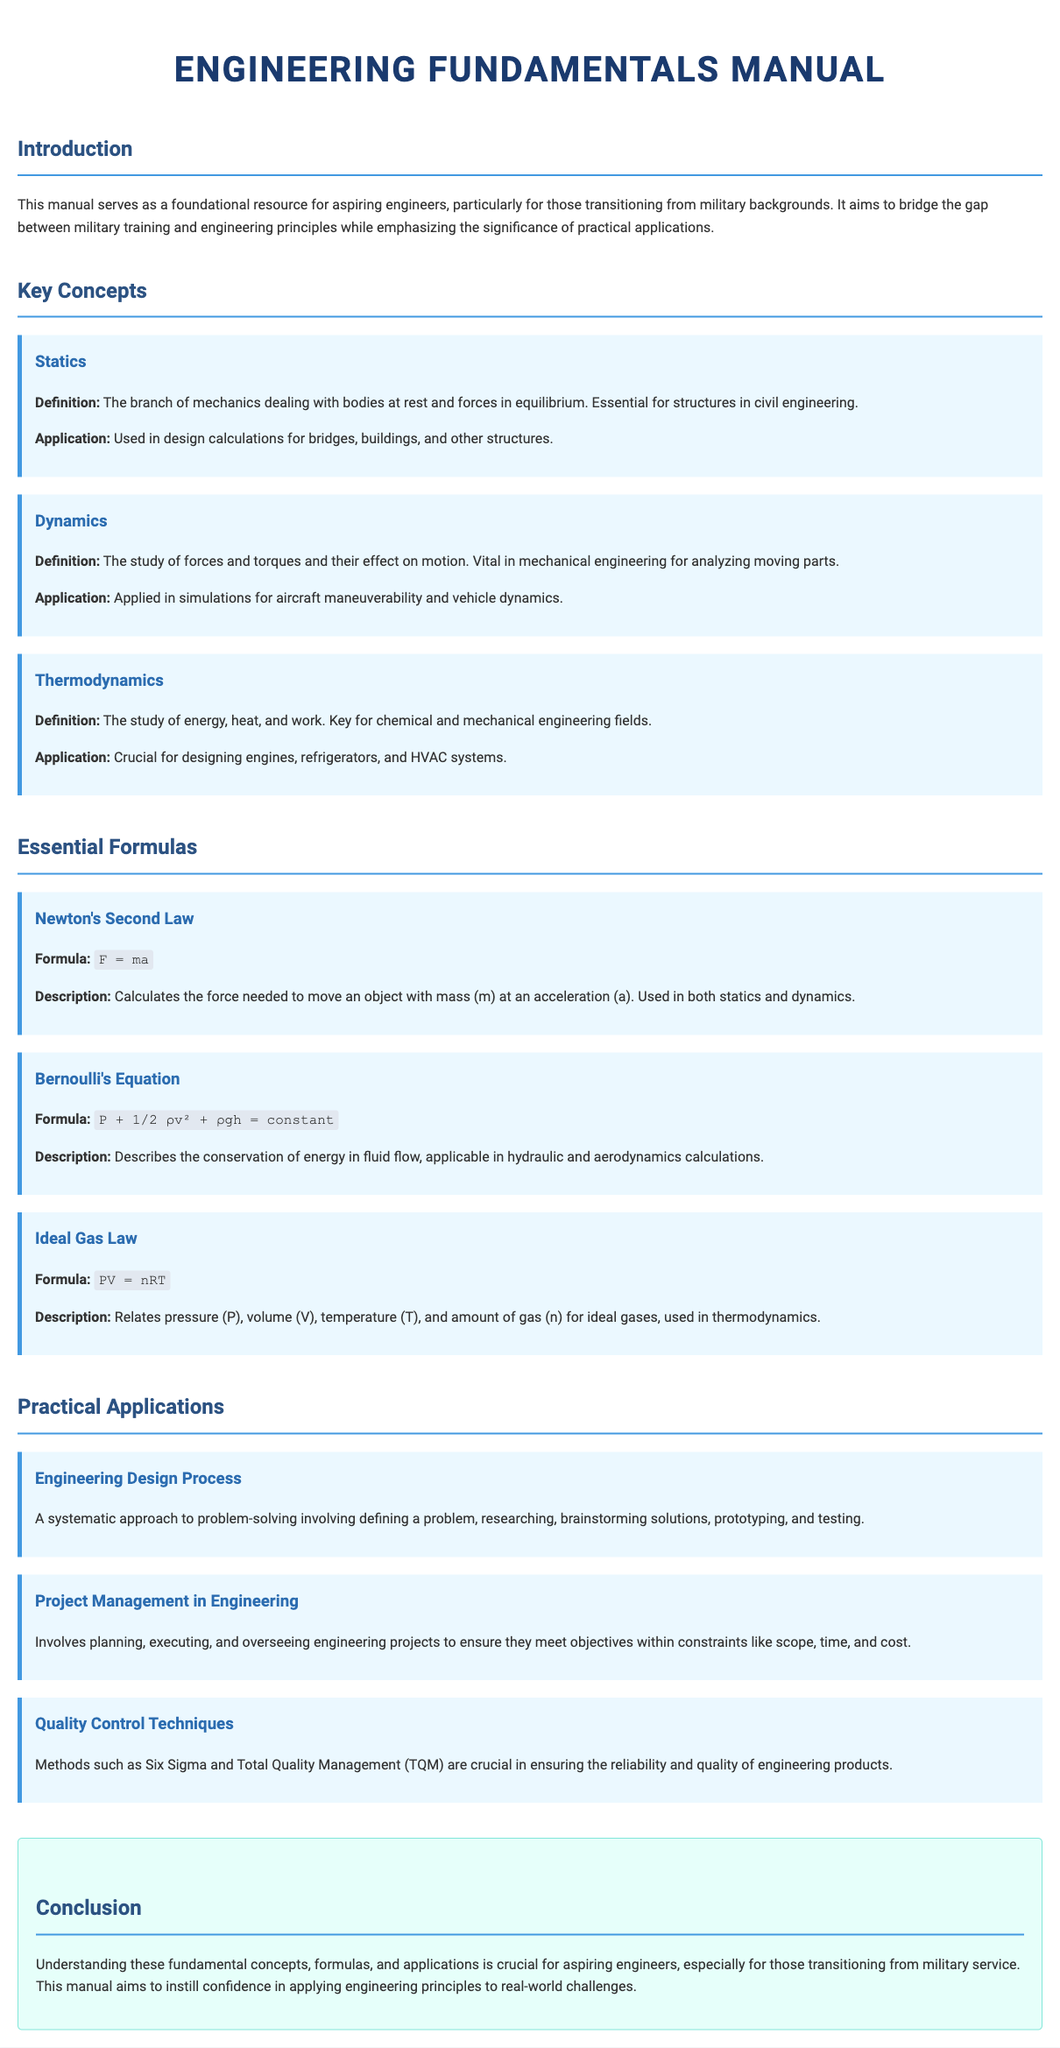What is the title of the manual? The title of the manual is stated at the beginning of the document.
Answer: Engineering Fundamentals Manual What is the main purpose of the manual? The purpose is outlined in the introduction section.
Answer: Foundational resource for aspiring engineers How many key concepts are listed in the manual? The manual explicitly states the number of key concepts discussed.
Answer: Three What is the first essential formula mentioned? The first formula can be identified in the Essential Formulas section.
Answer: Newton's Second Law What does Bernoulli's Equation describe? The purpose of Bernoulli's Equation is described in its corresponding section.
Answer: Conservation of energy in fluid flow What systematic approach is mentioned in the practical applications? This is detailed under the Engineering Design Process application.
Answer: Problem-solving What are the key quality control techniques mentioned? The techniques are described in the Quality Control Techniques application section.
Answer: Six Sigma and Total Quality Management Why is thermodynamics important for engineers? The importance is discussed under the Thermodynamics key concept section.
Answer: Designing engines, refrigerators, and HVAC systems What does the conclusion emphasize for aspiring engineers? The conclusion summarizes the key takeaways from the manual.
Answer: Understanding fundamental concepts and applications 